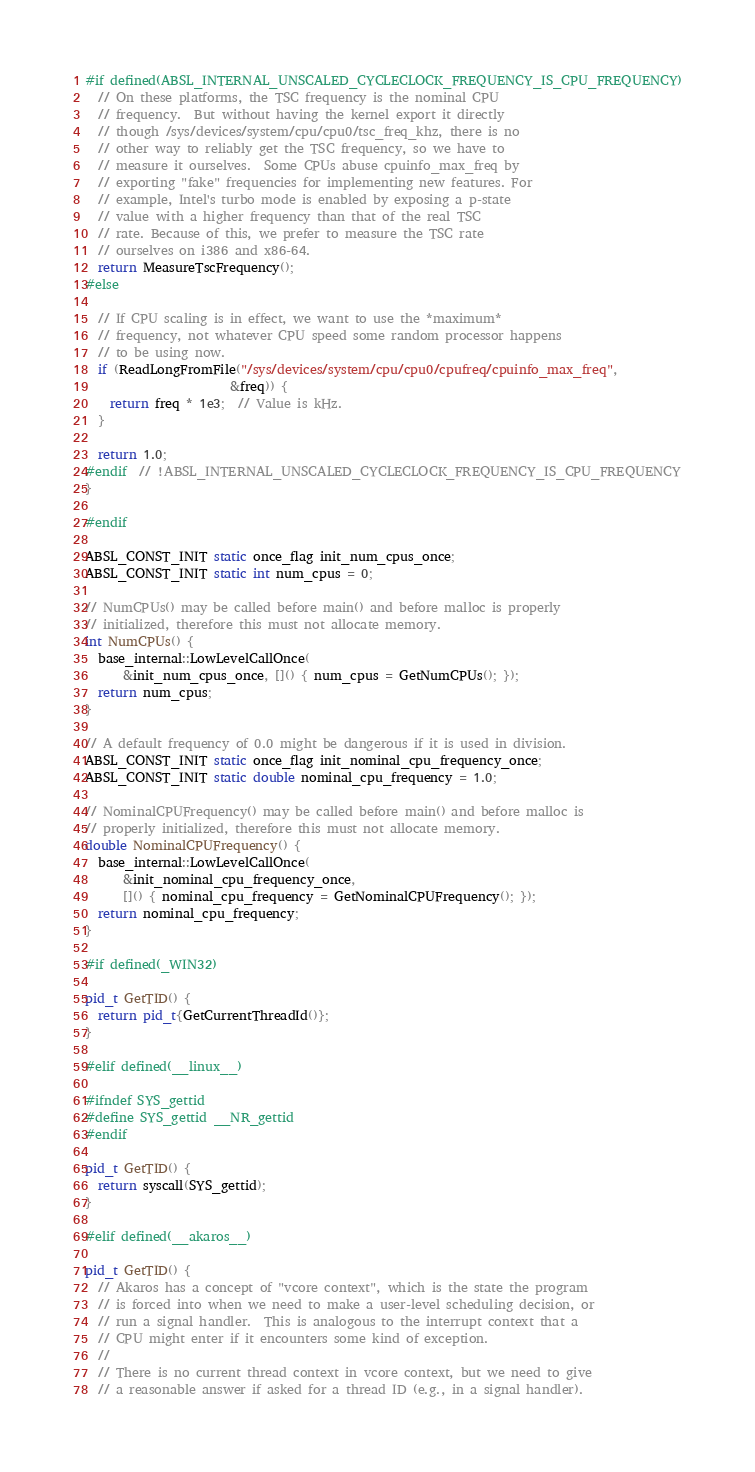<code> <loc_0><loc_0><loc_500><loc_500><_C++_>
#if defined(ABSL_INTERNAL_UNSCALED_CYCLECLOCK_FREQUENCY_IS_CPU_FREQUENCY)
  // On these platforms, the TSC frequency is the nominal CPU
  // frequency.  But without having the kernel export it directly
  // though /sys/devices/system/cpu/cpu0/tsc_freq_khz, there is no
  // other way to reliably get the TSC frequency, so we have to
  // measure it ourselves.  Some CPUs abuse cpuinfo_max_freq by
  // exporting "fake" frequencies for implementing new features. For
  // example, Intel's turbo mode is enabled by exposing a p-state
  // value with a higher frequency than that of the real TSC
  // rate. Because of this, we prefer to measure the TSC rate
  // ourselves on i386 and x86-64.
  return MeasureTscFrequency();
#else

  // If CPU scaling is in effect, we want to use the *maximum*
  // frequency, not whatever CPU speed some random processor happens
  // to be using now.
  if (ReadLongFromFile("/sys/devices/system/cpu/cpu0/cpufreq/cpuinfo_max_freq",
                       &freq)) {
    return freq * 1e3;  // Value is kHz.
  }

  return 1.0;
#endif  // !ABSL_INTERNAL_UNSCALED_CYCLECLOCK_FREQUENCY_IS_CPU_FREQUENCY
}

#endif

ABSL_CONST_INIT static once_flag init_num_cpus_once;
ABSL_CONST_INIT static int num_cpus = 0;

// NumCPUs() may be called before main() and before malloc is properly
// initialized, therefore this must not allocate memory.
int NumCPUs() {
  base_internal::LowLevelCallOnce(
      &init_num_cpus_once, []() { num_cpus = GetNumCPUs(); });
  return num_cpus;
}

// A default frequency of 0.0 might be dangerous if it is used in division.
ABSL_CONST_INIT static once_flag init_nominal_cpu_frequency_once;
ABSL_CONST_INIT static double nominal_cpu_frequency = 1.0;

// NominalCPUFrequency() may be called before main() and before malloc is
// properly initialized, therefore this must not allocate memory.
double NominalCPUFrequency() {
  base_internal::LowLevelCallOnce(
      &init_nominal_cpu_frequency_once,
      []() { nominal_cpu_frequency = GetNominalCPUFrequency(); });
  return nominal_cpu_frequency;
}

#if defined(_WIN32)

pid_t GetTID() {
  return pid_t{GetCurrentThreadId()};
}

#elif defined(__linux__)

#ifndef SYS_gettid
#define SYS_gettid __NR_gettid
#endif

pid_t GetTID() {
  return syscall(SYS_gettid);
}

#elif defined(__akaros__)

pid_t GetTID() {
  // Akaros has a concept of "vcore context", which is the state the program
  // is forced into when we need to make a user-level scheduling decision, or
  // run a signal handler.  This is analogous to the interrupt context that a
  // CPU might enter if it encounters some kind of exception.
  //
  // There is no current thread context in vcore context, but we need to give
  // a reasonable answer if asked for a thread ID (e.g., in a signal handler).</code> 